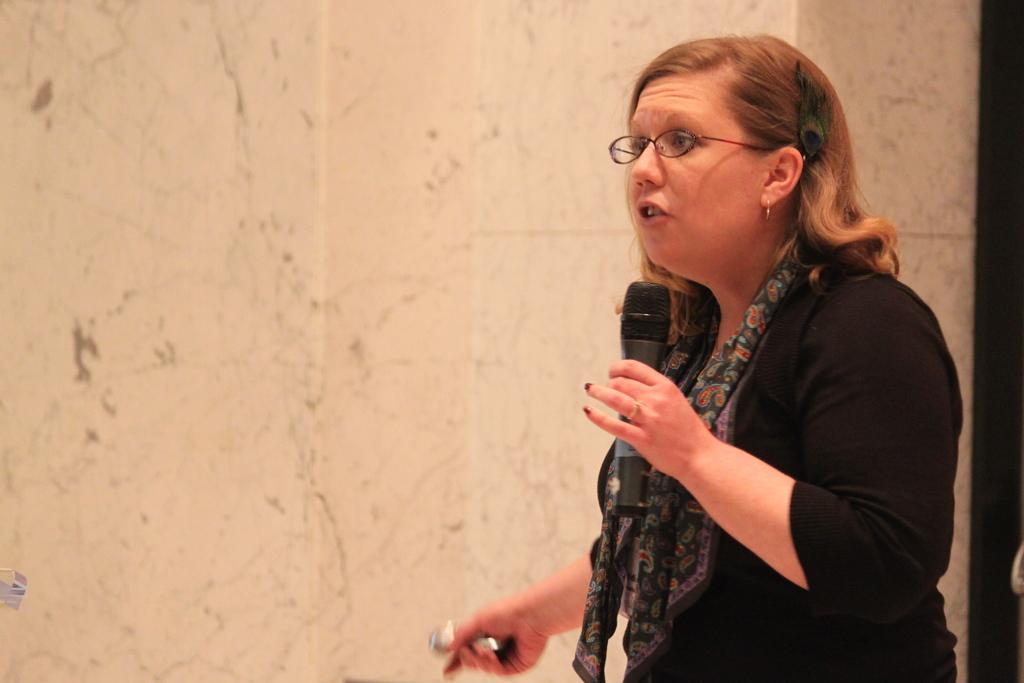What is the color of the wall in the image? The wall in the image is white. What is the woman in the image doing? The woman is talking on a microphone. What type of organization is the woman representing in the image? There is no information about an organization in the image, as it only shows a woman talking on a microphone in front of a white wall. What part of the woman's body is visible in the image? The image only shows the woman from the waist up, so it is not possible to determine the visibility of her flesh. 